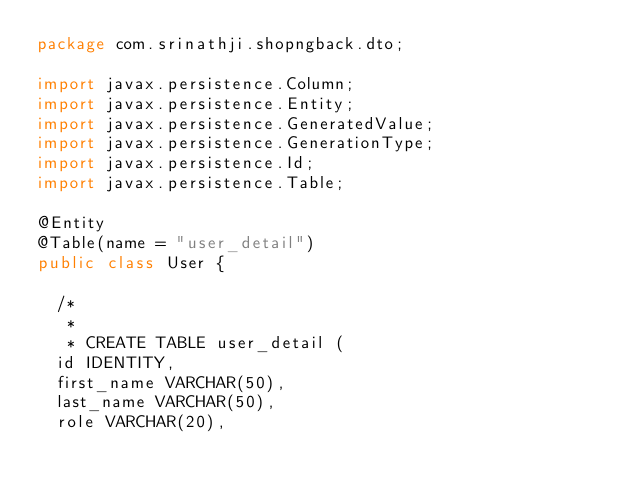<code> <loc_0><loc_0><loc_500><loc_500><_Java_>package com.srinathji.shopngback.dto;

import javax.persistence.Column;
import javax.persistence.Entity;
import javax.persistence.GeneratedValue;
import javax.persistence.GenerationType;
import javax.persistence.Id;
import javax.persistence.Table;

@Entity
@Table(name = "user_detail")
public class User {
	
	/*
	 * 
	 * CREATE TABLE user_detail (
 	id IDENTITY,
 	first_name VARCHAR(50),
 	last_name VARCHAR(50),
 	role VARCHAR(20),</code> 